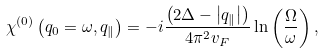Convert formula to latex. <formula><loc_0><loc_0><loc_500><loc_500>\chi ^ { ( 0 ) } \left ( q _ { 0 } = \omega , q _ { \| } \right ) = - i \frac { \left ( 2 \Delta - \left | q _ { \| } \right | \right ) } { 4 \pi ^ { 2 } v _ { F } } \ln \left ( \frac { \Omega } { \omega } \right ) ,</formula> 